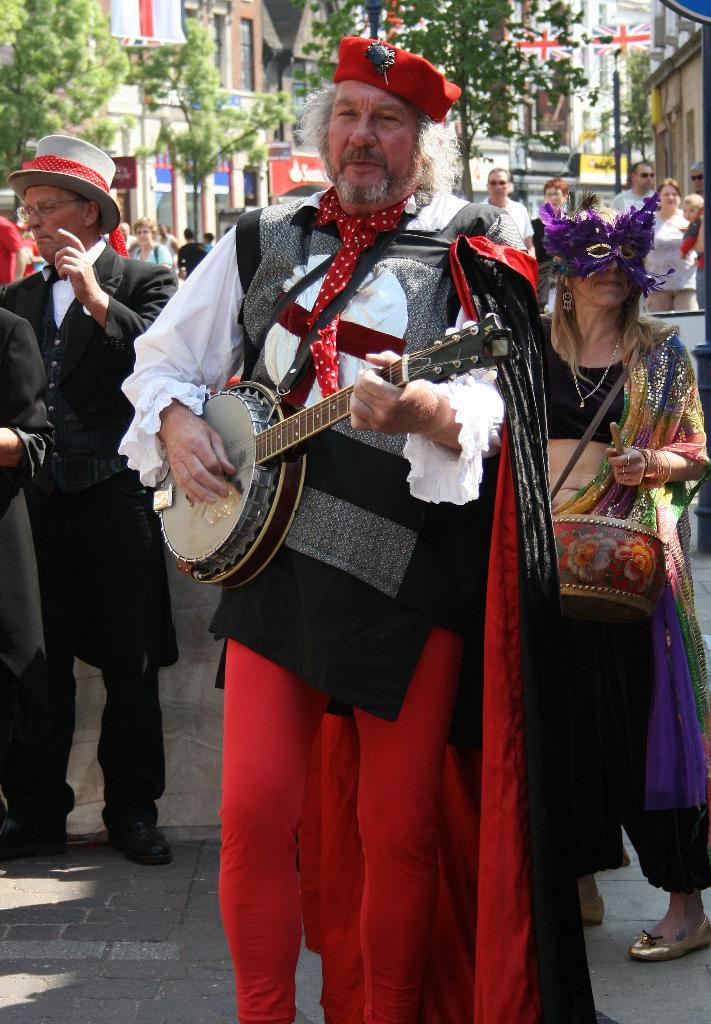How many people are in the image? There are people in the image, but the exact number is not specified. What are the people doing in the image? The people are standing on the road and playing musical instruments. What can be seen in the background of the image? Trees and buildings are visible in the background of the image. What are the people wearing in the image? The people are wearing different costumes in the image. What type of decision can be seen being made by the beetle in the image? There is no beetle present in the image, so no decision can be observed. 